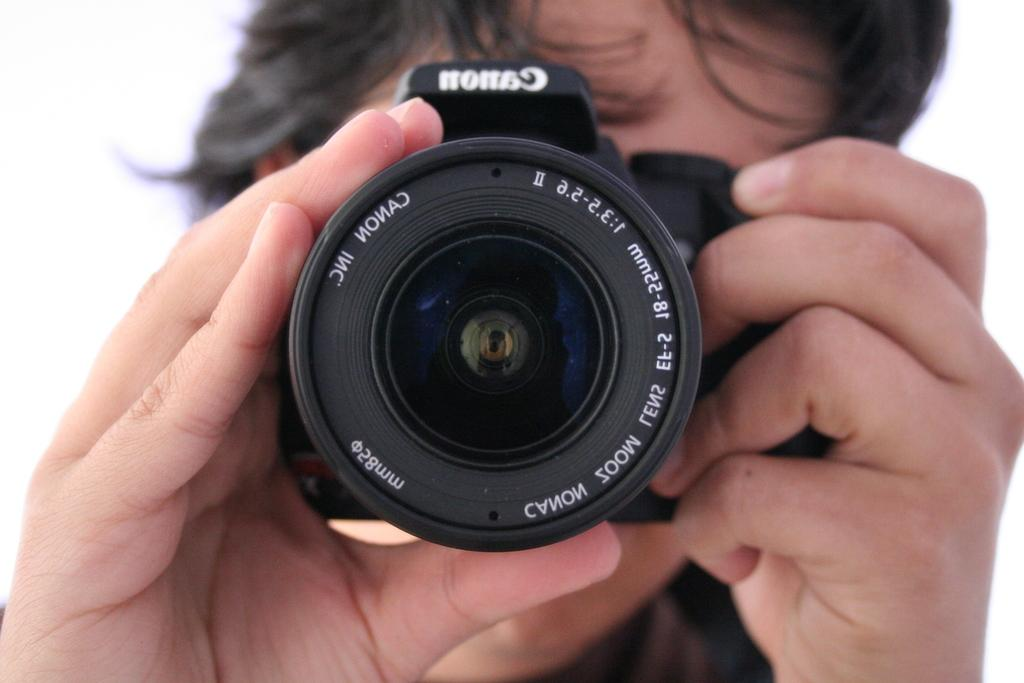<image>
Describe the image concisely. Person holding a Canon camera pointed straight ahead. 